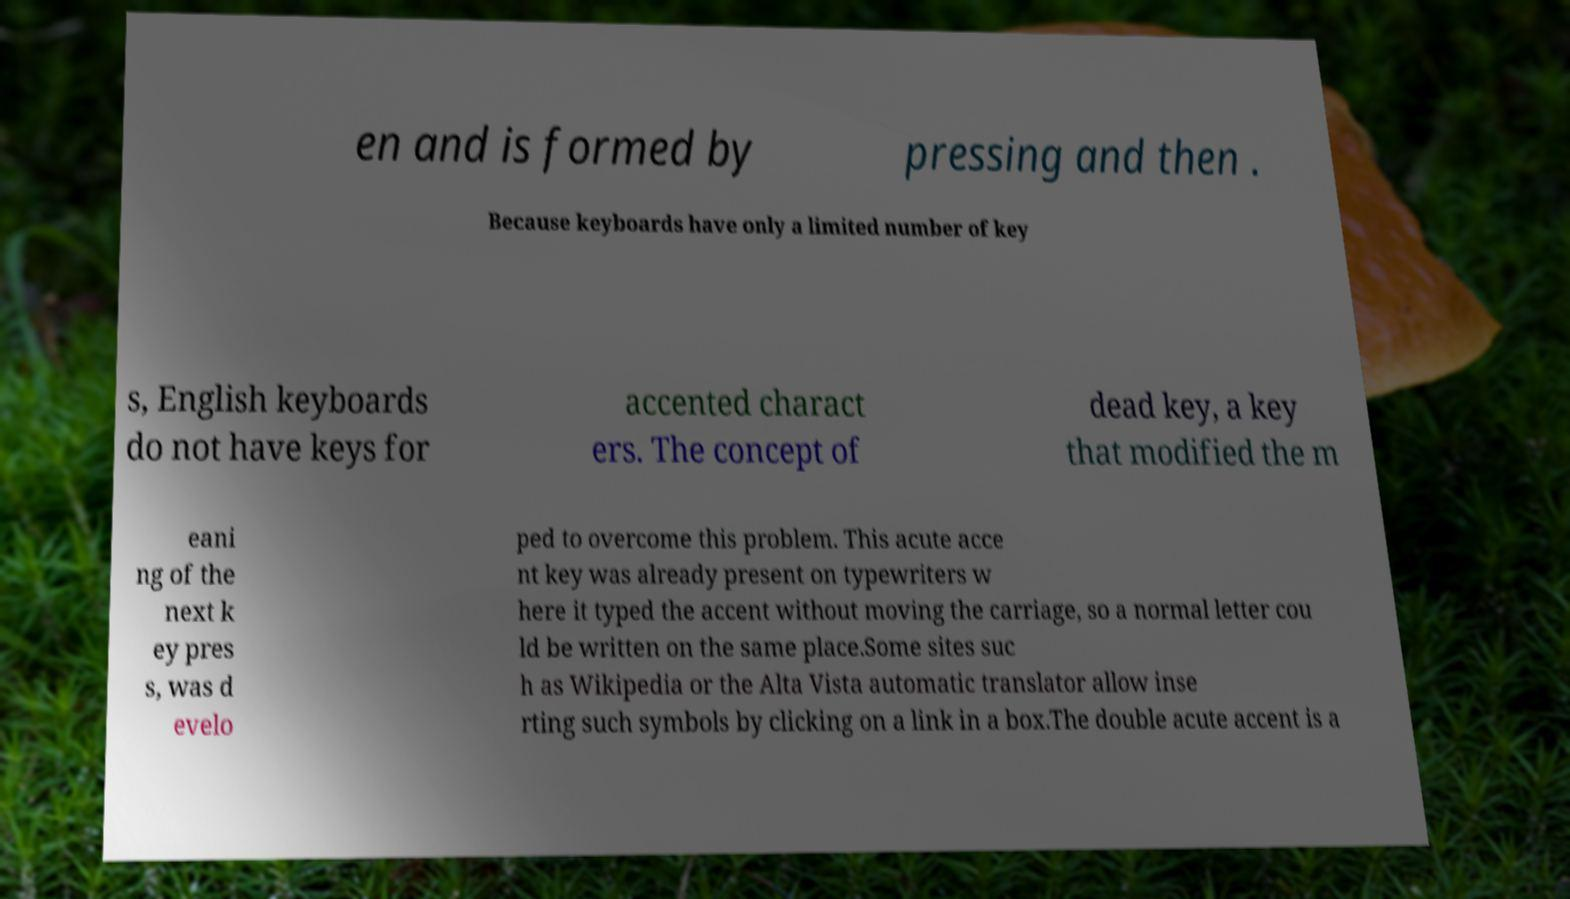There's text embedded in this image that I need extracted. Can you transcribe it verbatim? en and is formed by pressing and then . Because keyboards have only a limited number of key s, English keyboards do not have keys for accented charact ers. The concept of dead key, a key that modified the m eani ng of the next k ey pres s, was d evelo ped to overcome this problem. This acute acce nt key was already present on typewriters w here it typed the accent without moving the carriage, so a normal letter cou ld be written on the same place.Some sites suc h as Wikipedia or the Alta Vista automatic translator allow inse rting such symbols by clicking on a link in a box.The double acute accent is a 